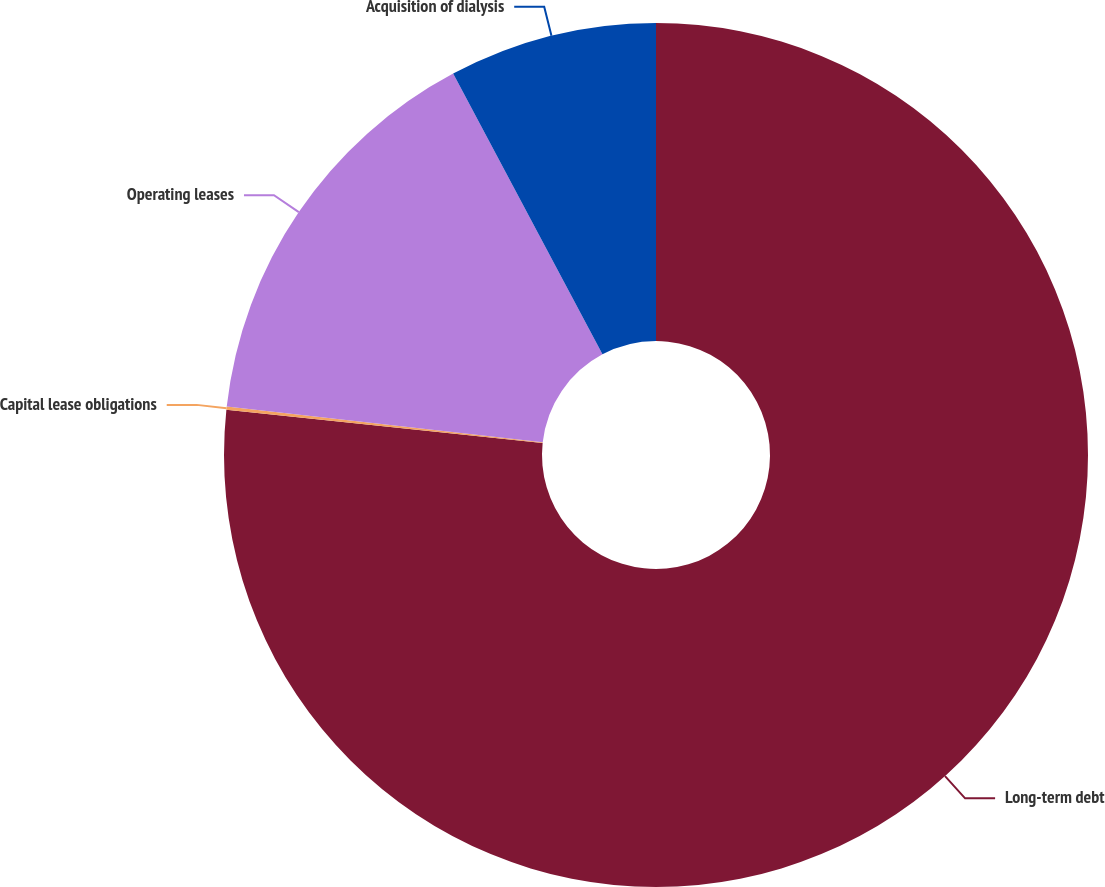<chart> <loc_0><loc_0><loc_500><loc_500><pie_chart><fcel>Long-term debt<fcel>Capital lease obligations<fcel>Operating leases<fcel>Acquisition of dialysis<nl><fcel>76.67%<fcel>0.12%<fcel>15.43%<fcel>7.78%<nl></chart> 